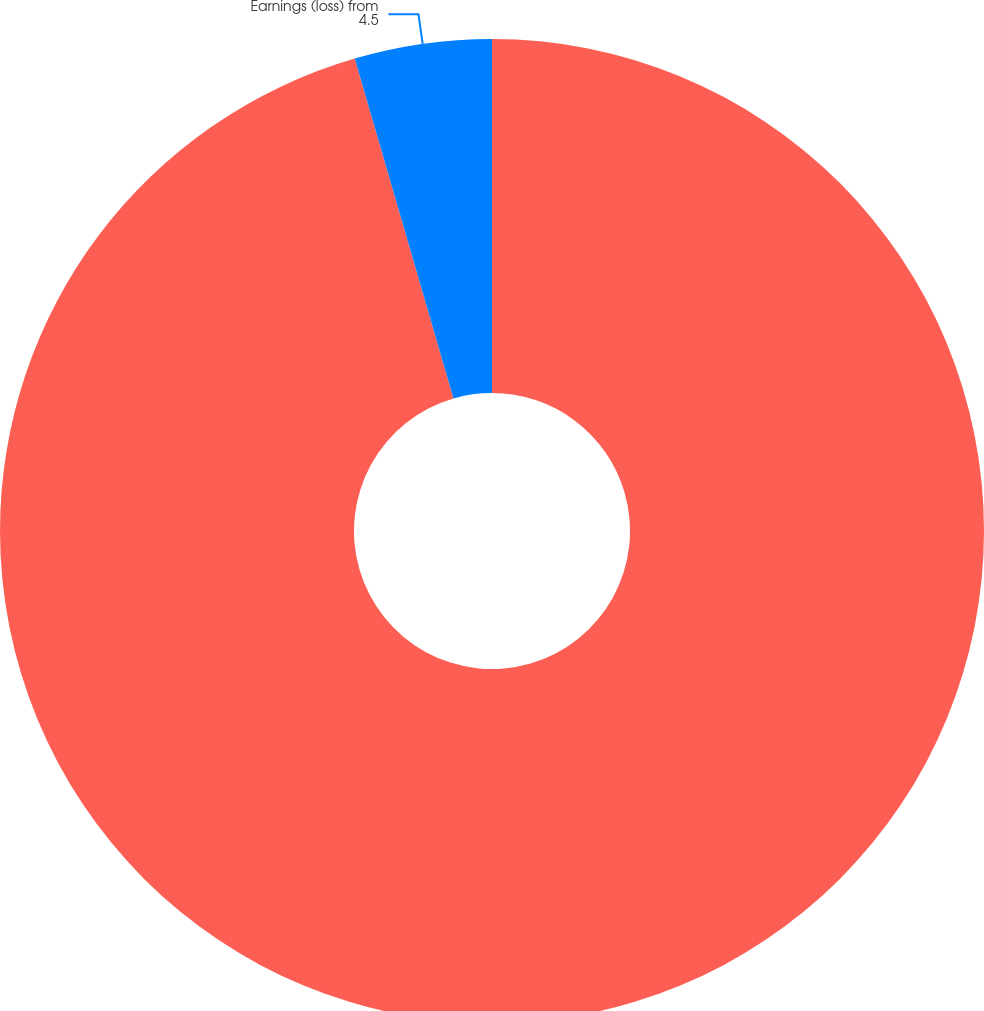Convert chart to OTSL. <chart><loc_0><loc_0><loc_500><loc_500><pie_chart><fcel>Net revenue<fcel>Earnings (loss) from<nl><fcel>95.5%<fcel>4.5%<nl></chart> 